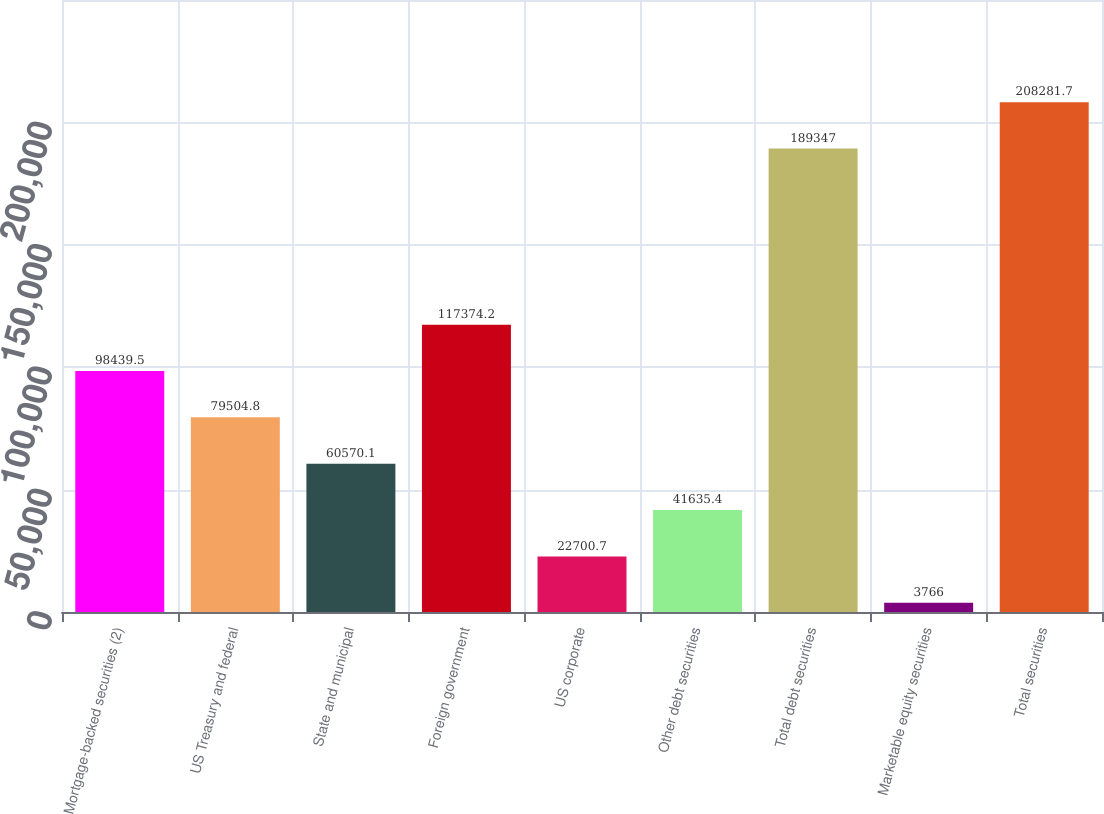Convert chart. <chart><loc_0><loc_0><loc_500><loc_500><bar_chart><fcel>Mortgage-backed securities (2)<fcel>US Treasury and federal<fcel>State and municipal<fcel>Foreign government<fcel>US corporate<fcel>Other debt securities<fcel>Total debt securities<fcel>Marketable equity securities<fcel>Total securities<nl><fcel>98439.5<fcel>79504.8<fcel>60570.1<fcel>117374<fcel>22700.7<fcel>41635.4<fcel>189347<fcel>3766<fcel>208282<nl></chart> 